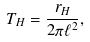Convert formula to latex. <formula><loc_0><loc_0><loc_500><loc_500>T _ { H } = \frac { r _ { H } } { 2 \pi \ell ^ { 2 } } ,</formula> 